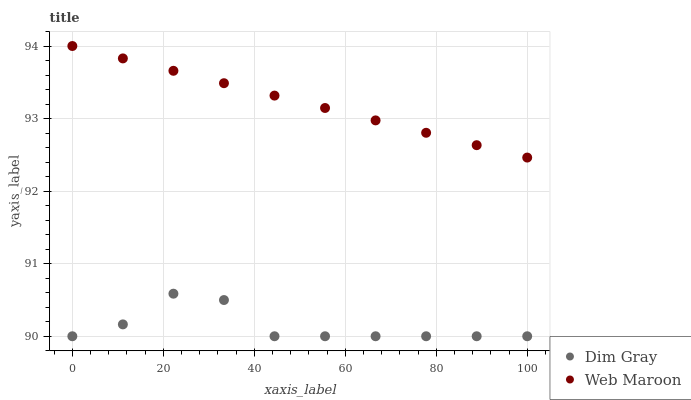Does Dim Gray have the minimum area under the curve?
Answer yes or no. Yes. Does Web Maroon have the maximum area under the curve?
Answer yes or no. Yes. Does Web Maroon have the minimum area under the curve?
Answer yes or no. No. Is Web Maroon the smoothest?
Answer yes or no. Yes. Is Dim Gray the roughest?
Answer yes or no. Yes. Is Web Maroon the roughest?
Answer yes or no. No. Does Dim Gray have the lowest value?
Answer yes or no. Yes. Does Web Maroon have the lowest value?
Answer yes or no. No. Does Web Maroon have the highest value?
Answer yes or no. Yes. Is Dim Gray less than Web Maroon?
Answer yes or no. Yes. Is Web Maroon greater than Dim Gray?
Answer yes or no. Yes. Does Dim Gray intersect Web Maroon?
Answer yes or no. No. 